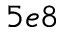<formula> <loc_0><loc_0><loc_500><loc_500>5 e 8</formula> 